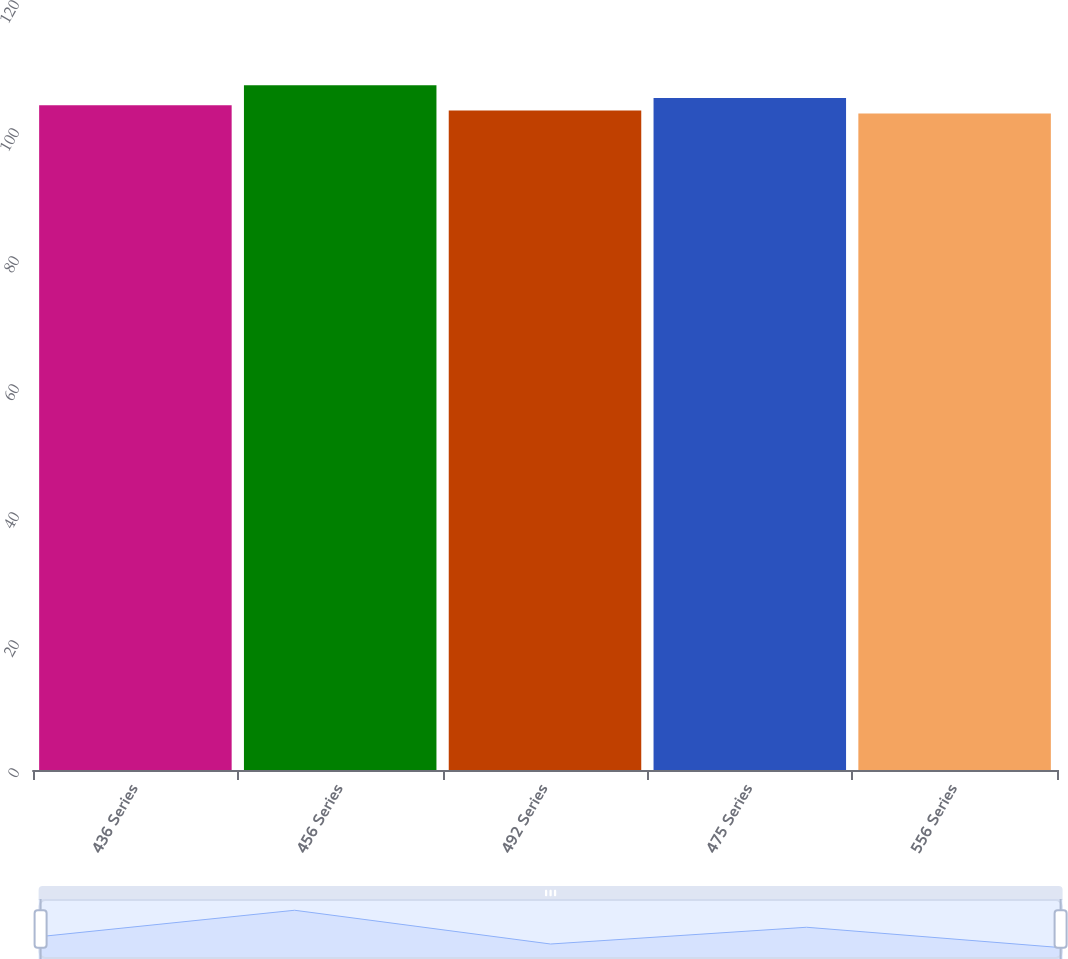Convert chart. <chart><loc_0><loc_0><loc_500><loc_500><bar_chart><fcel>436 Series<fcel>456 Series<fcel>492 Series<fcel>475 Series<fcel>556 Series<nl><fcel>103.88<fcel>107<fcel>103.03<fcel>105<fcel>102.59<nl></chart> 